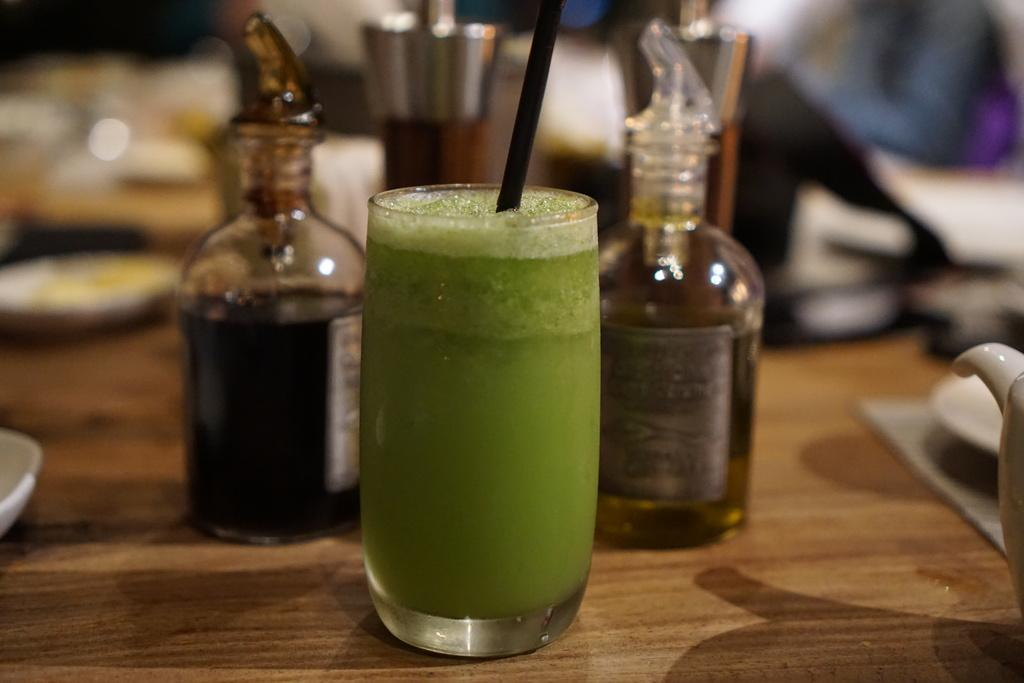What is present on the table in the image? There is a glass and two bottles on the table in the image. Can you describe the glass in the image? The glass is one of the items on the table. How many bottles are visible in the image? There are two bottles in the image. How many babies are present in the image? There are no babies present in the image; it only features a glass and two bottles on a table. 